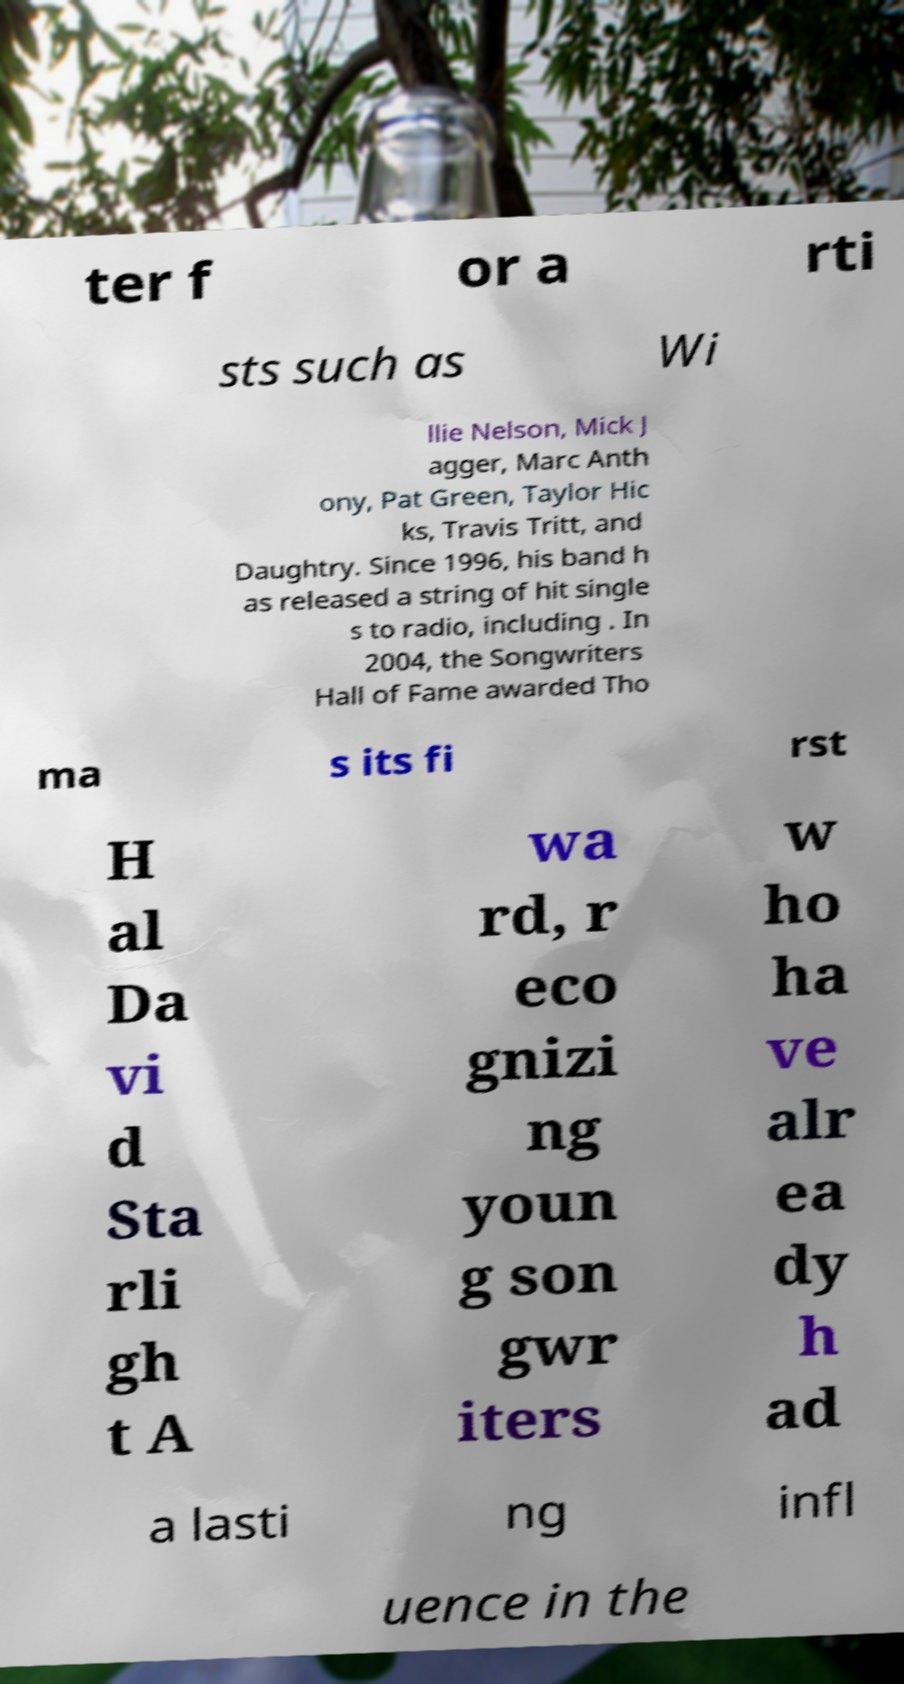What messages or text are displayed in this image? I need them in a readable, typed format. ter f or a rti sts such as Wi llie Nelson, Mick J agger, Marc Anth ony, Pat Green, Taylor Hic ks, Travis Tritt, and Daughtry. Since 1996, his band h as released a string of hit single s to radio, including . In 2004, the Songwriters Hall of Fame awarded Tho ma s its fi rst H al Da vi d Sta rli gh t A wa rd, r eco gnizi ng youn g son gwr iters w ho ha ve alr ea dy h ad a lasti ng infl uence in the 